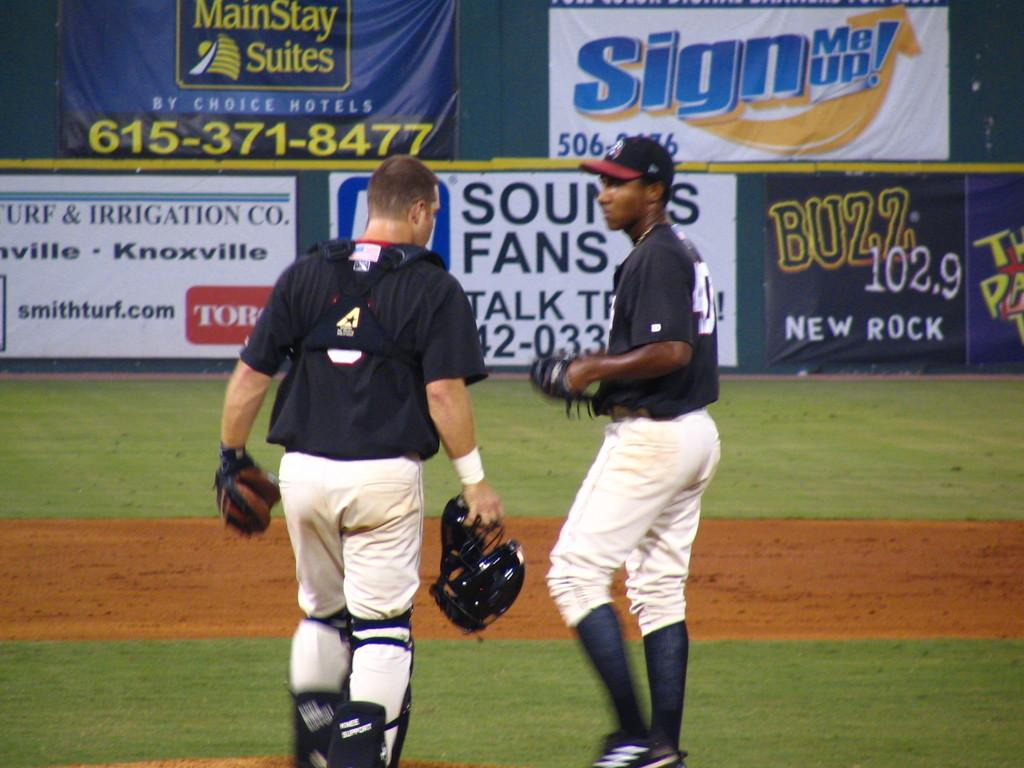<image>
Create a compact narrative representing the image presented. a couple of players side by side with a Buzz sign in the outfield 